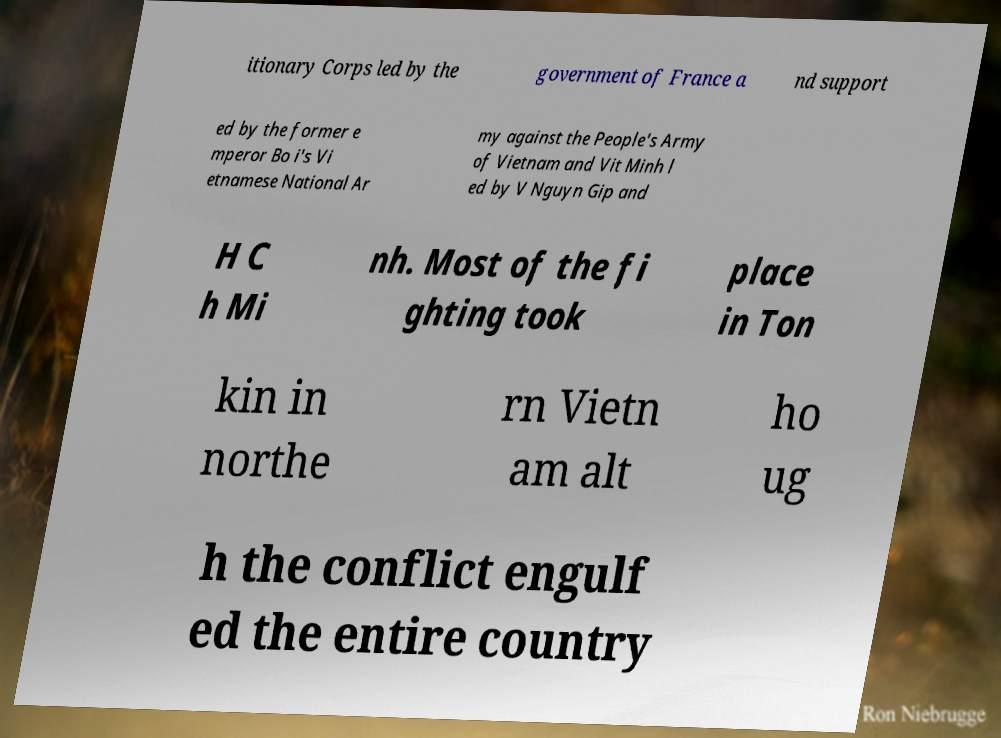Please read and relay the text visible in this image. What does it say? itionary Corps led by the government of France a nd support ed by the former e mperor Bo i's Vi etnamese National Ar my against the People's Army of Vietnam and Vit Minh l ed by V Nguyn Gip and H C h Mi nh. Most of the fi ghting took place in Ton kin in northe rn Vietn am alt ho ug h the conflict engulf ed the entire country 